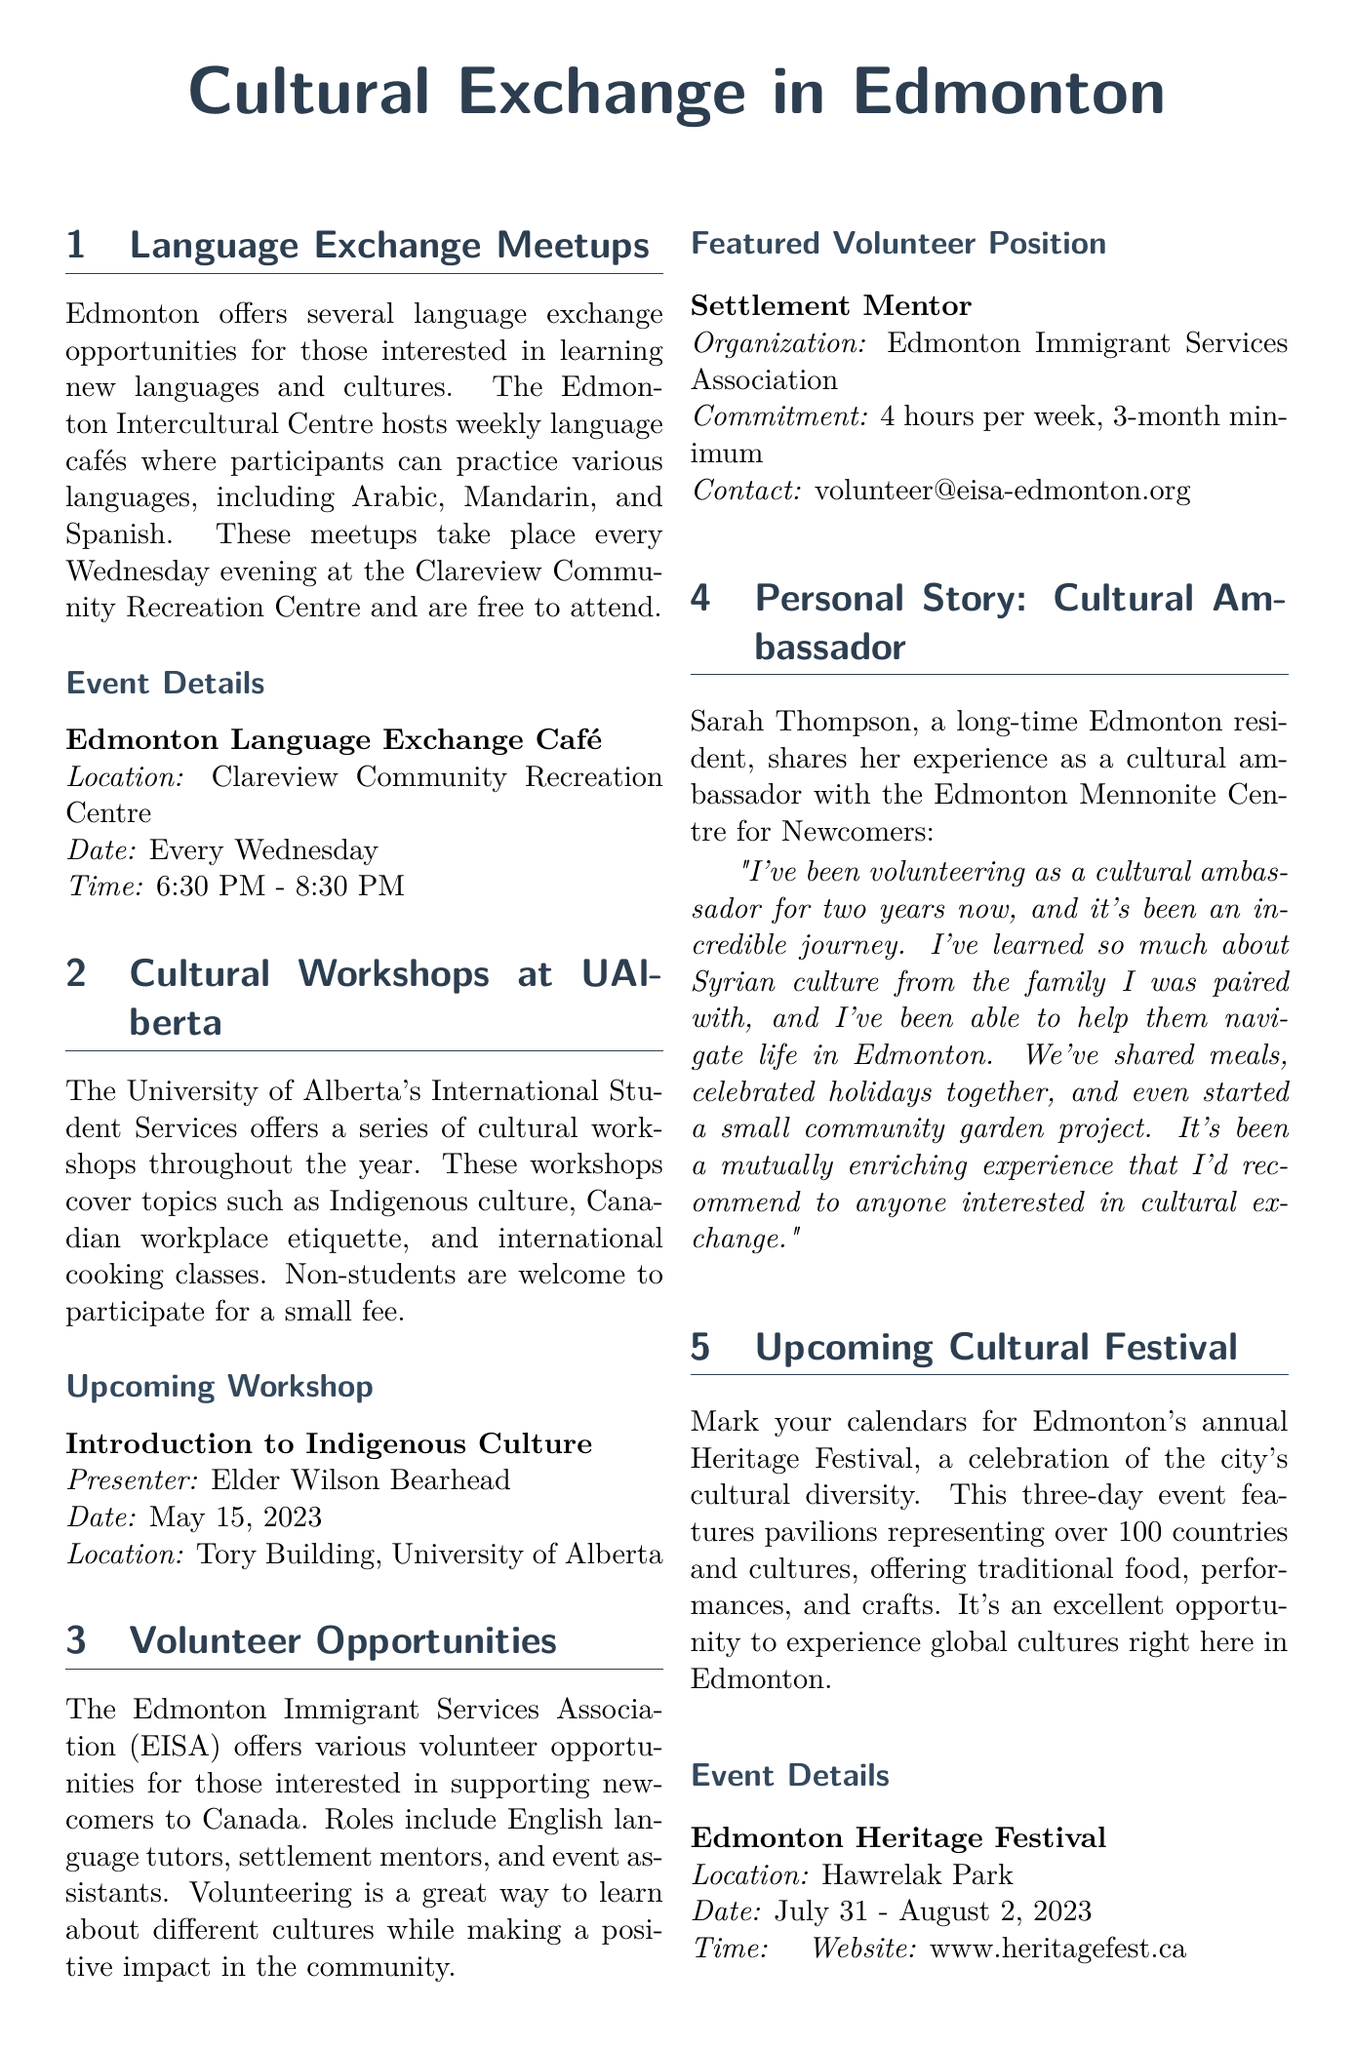What time does the language exchange café start? The language exchange café starts at 6:30 PM.
Answer: 6:30 PM Who is presenting the upcoming workshop on Indigenous culture? The presenter of the upcoming workshop is Elder Wilson Bearhead.
Answer: Elder Wilson Bearhead How long is the commitment for the settlement mentor volunteer position? The commitment for the settlement mentor is a minimum of 3 months.
Answer: 3 months What is the name of the cultural festival mentioned in the newsletter? The name of the cultural festival is the Heritage Festival.
Answer: Heritage Festival What type of events do the language cafés offer? The language cafés offer opportunities to practice various languages.
Answer: Practice various languages Which organization offers the volunteer opportunities mentioned? The volunteer opportunities are offered by the Edmonton Immigrant Services Association.
Answer: Edmonton Immigrant Services Association When does the Heritage Festival take place? The Heritage Festival takes place from July 31 to August 2, 2023.
Answer: July 31 - August 2, 2023 What is one personal experience shared by Sarah Thompson? Sarah Thompson shared about celebrating holidays together.
Answer: Celebrating holidays together How often do the language exchange meetups occur? The language exchange meetups occur every Wednesday.
Answer: Every Wednesday 